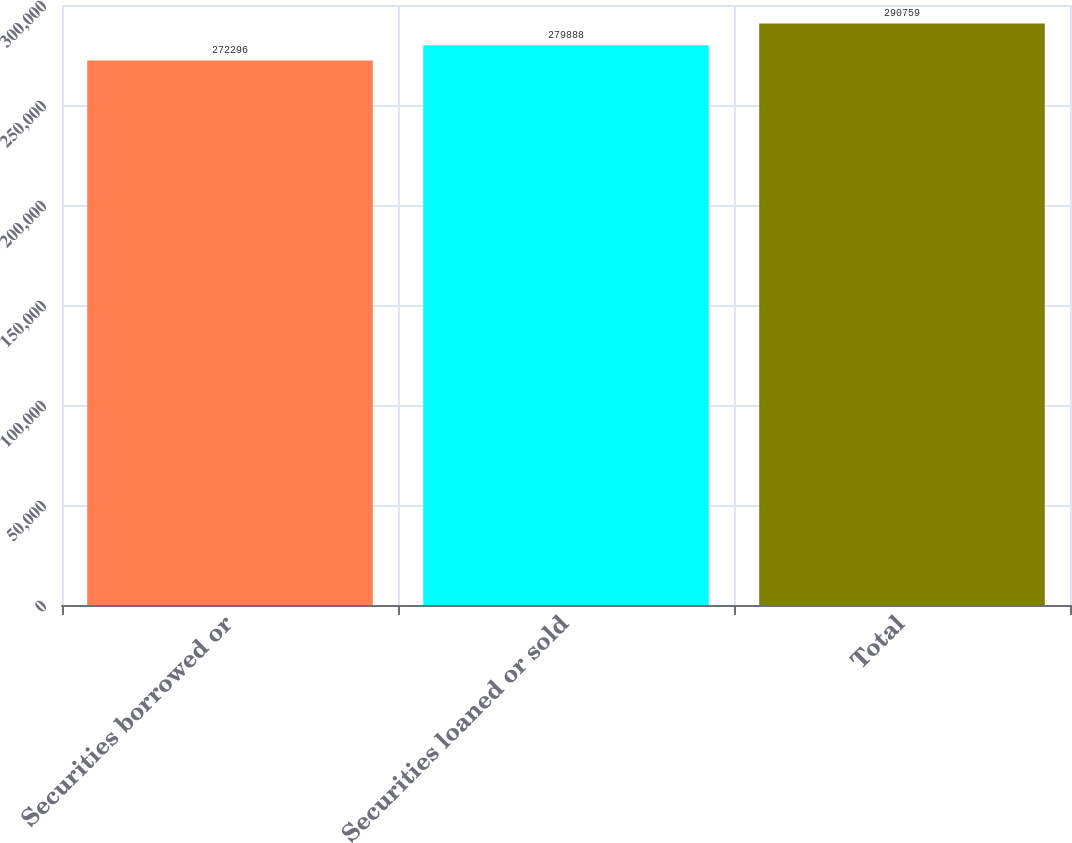Convert chart to OTSL. <chart><loc_0><loc_0><loc_500><loc_500><bar_chart><fcel>Securities borrowed or<fcel>Securities loaned or sold<fcel>Total<nl><fcel>272296<fcel>279888<fcel>290759<nl></chart> 